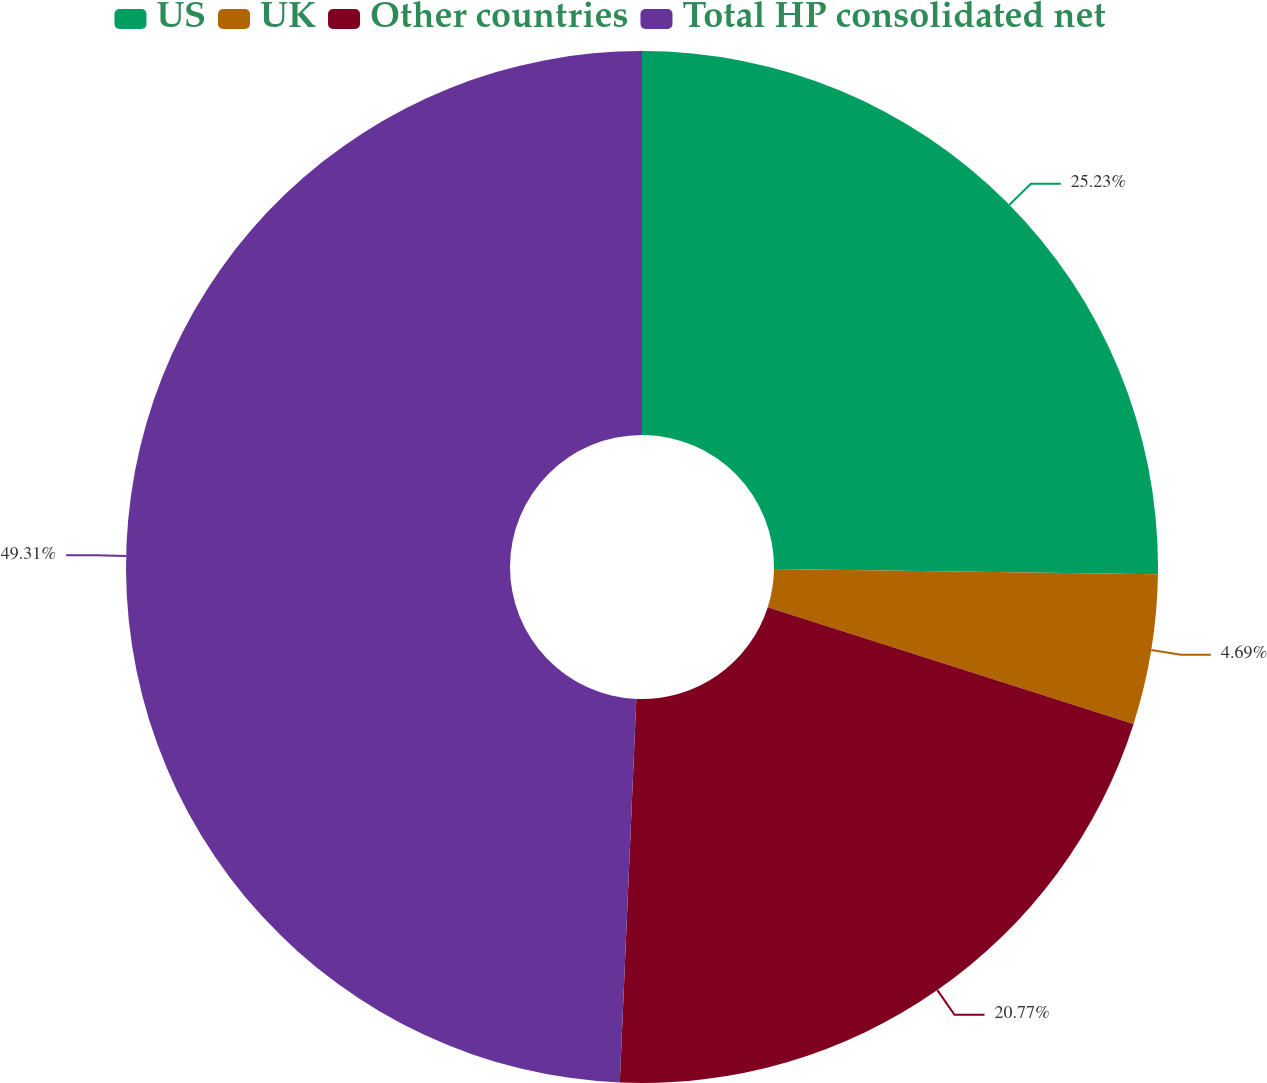Convert chart. <chart><loc_0><loc_0><loc_500><loc_500><pie_chart><fcel>US<fcel>UK<fcel>Other countries<fcel>Total HP consolidated net<nl><fcel>25.23%<fcel>4.69%<fcel>20.77%<fcel>49.32%<nl></chart> 